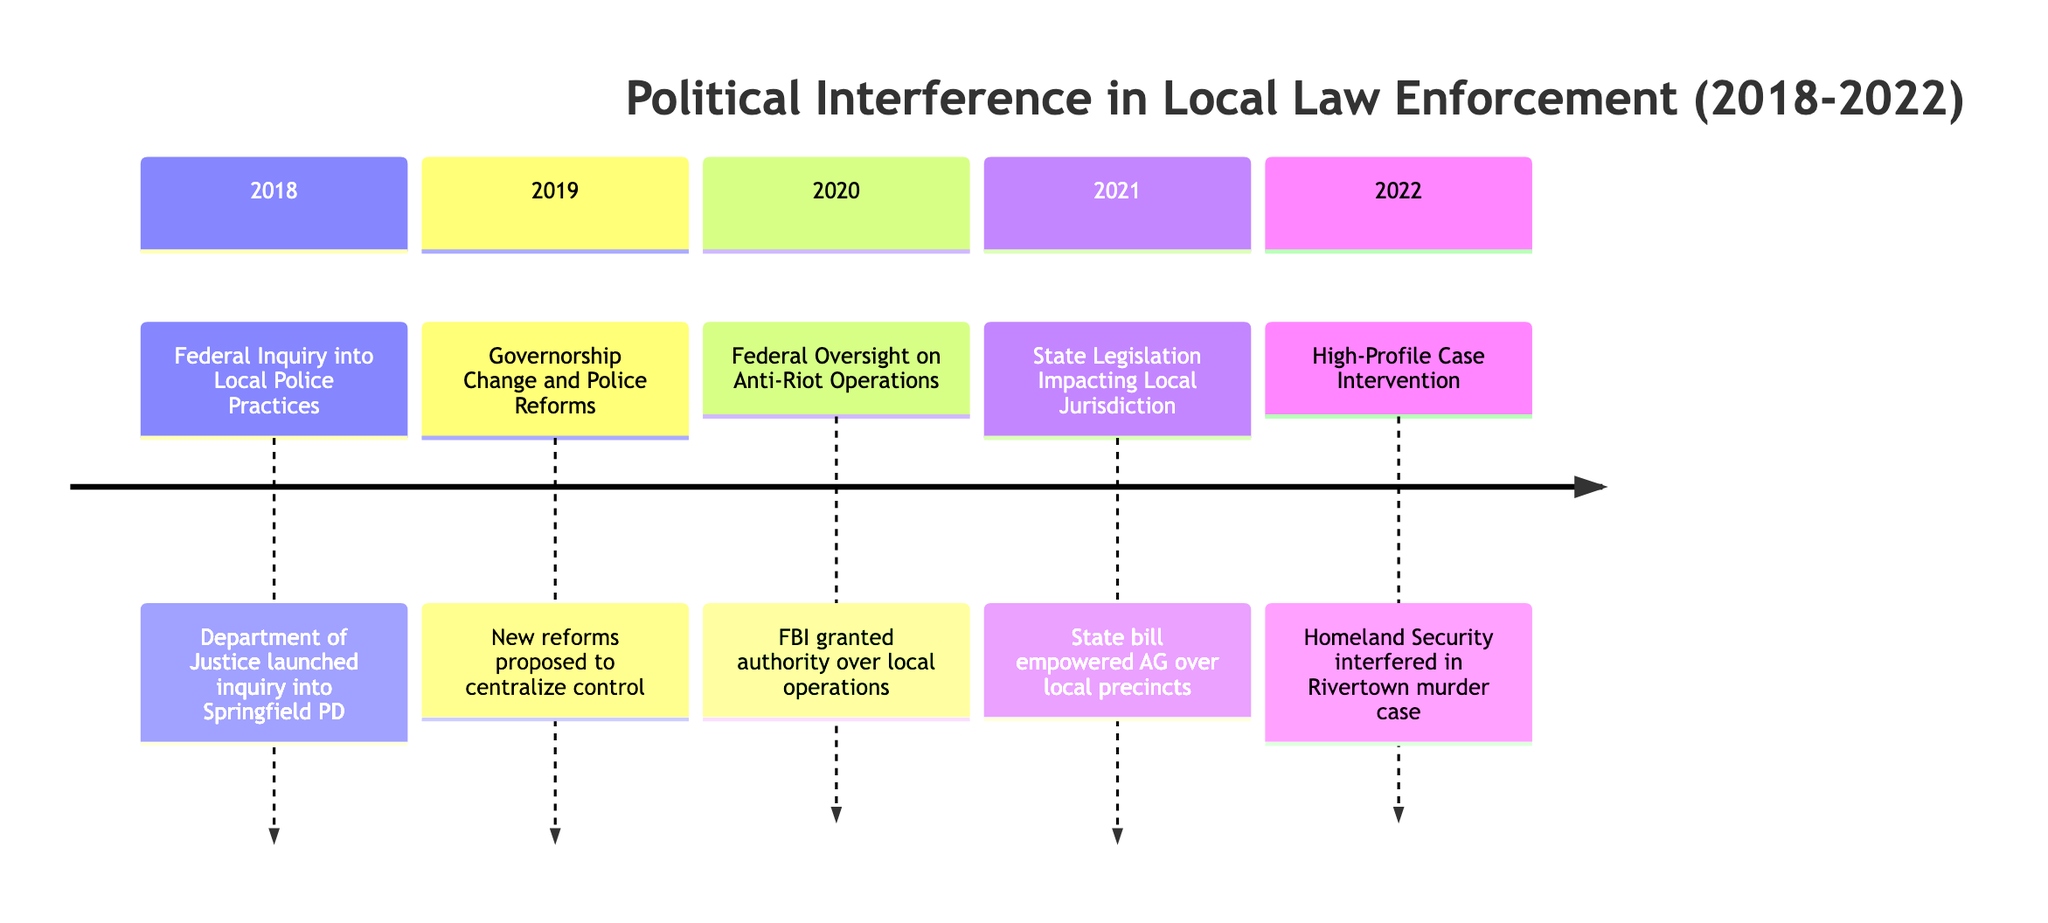What's the first event in the timeline? The first event listed in the timeline is "Federal Inquiry into Local Police Practices," which occurred on March 15, 2018. This can be identified as the earliest date in the chronological order of events presented.
Answer: Federal Inquiry into Local Police Practices How many events are listed in the timeline? There are five events documented in the timeline from 2018 to 2022. This is determined by counting the separate occurrences listed under each year.
Answer: 5 Which event occurred in 2021? The event that took place in 2021 is "State Legislation Impacting Local Jurisdiction." This can be identified by looking for the listed events under the 2021 section of the timeline.
Answer: State Legislation Impacting Local Jurisdiction What was the main focus of the event on June 22, 2019? The event on June 22, 2019, was focused on the "Governorship Change and Police Reforms," which involved proposed reforms to centralize control over local law enforcement. This can be inferred from the description associated with that date.
Answer: Governorship Change and Police Reforms What federal agency was involved in overseeing local anti-riot operations in 2020? The FBI was the federal agency that was granted authority to oversee local anti-riot operations in 2020, as described in the timeline. This information is directly stated in the description of the event.
Answer: FBI What impact did the 2022 intervention have on local law enforcement? The intervention in the high-profile murder investigation in Rivertown by the Homeland Security Department intensified local-federal friction and questioned the local force's competence, as detailed in the event description.
Answer: Intensified friction What was a consequence of the state legislation passed in 2021? A consequence of the state legislation passed in 2021 was that it limited the independence of local precincts by empowering the Attorney General over certain investigations. This result is specifically mentioned in the description of that event.
Answer: Limited independence Which event involved protests among local police unions? The event that involved protests among local police unions is the "Governorship Change and Police Reforms" in 2019, which resulted from proposed reforms that reduced municipal autonomy. This can be found in the description of that event.
Answer: Governorship Change and Police Reforms 